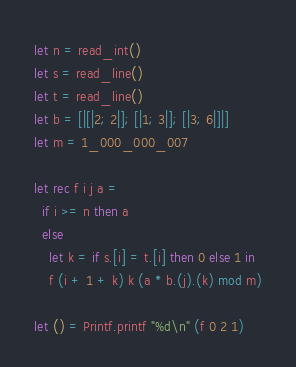Convert code to text. <code><loc_0><loc_0><loc_500><loc_500><_OCaml_>let n = read_int()
let s = read_line()
let t = read_line()
let b = [|[|2; 2|]; [|1; 3|]; [|3; 6|]|]
let m = 1_000_000_007

let rec f i j a =
  if i >= n then a
  else
    let k = if s.[i] = t.[i] then 0 else 1 in
    f (i + 1 + k) k (a * b.(j).(k) mod m)

let () = Printf.printf "%d\n" (f 0 2 1)
</code> 